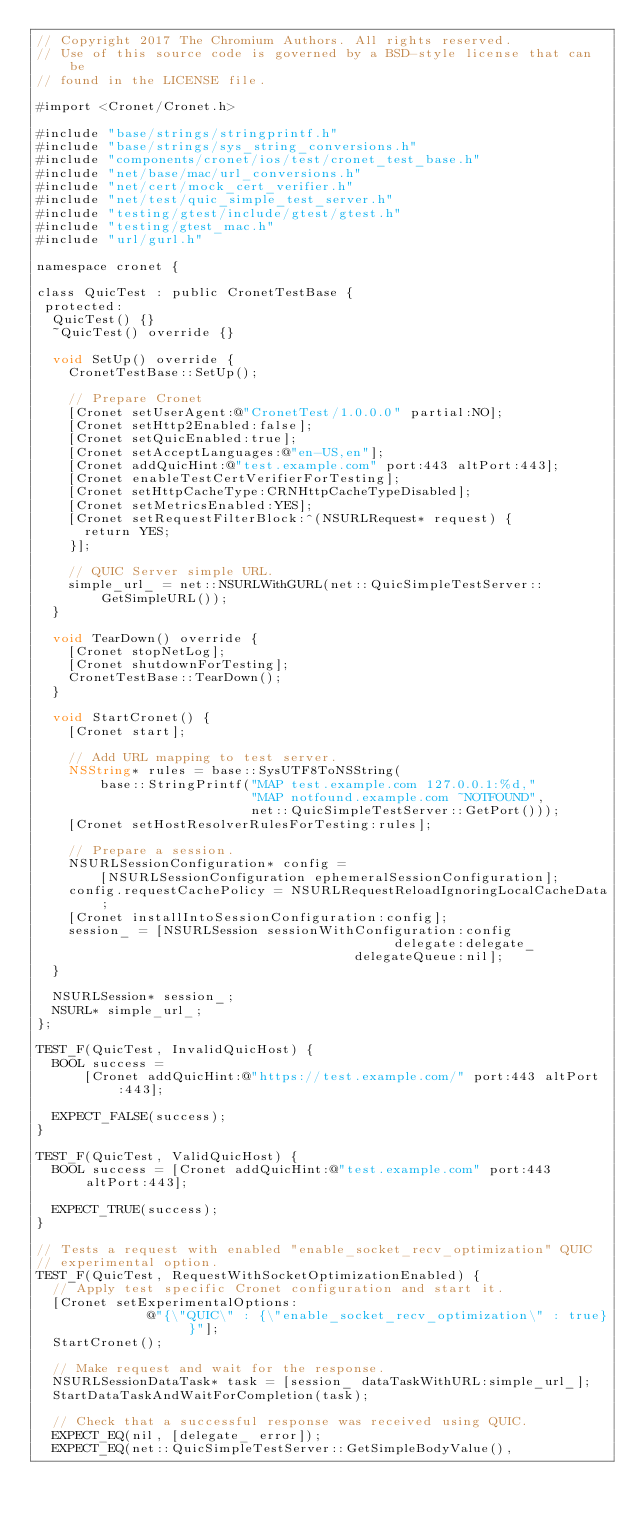<code> <loc_0><loc_0><loc_500><loc_500><_ObjectiveC_>// Copyright 2017 The Chromium Authors. All rights reserved.
// Use of this source code is governed by a BSD-style license that can be
// found in the LICENSE file.

#import <Cronet/Cronet.h>

#include "base/strings/stringprintf.h"
#include "base/strings/sys_string_conversions.h"
#include "components/cronet/ios/test/cronet_test_base.h"
#include "net/base/mac/url_conversions.h"
#include "net/cert/mock_cert_verifier.h"
#include "net/test/quic_simple_test_server.h"
#include "testing/gtest/include/gtest/gtest.h"
#include "testing/gtest_mac.h"
#include "url/gurl.h"

namespace cronet {

class QuicTest : public CronetTestBase {
 protected:
  QuicTest() {}
  ~QuicTest() override {}

  void SetUp() override {
    CronetTestBase::SetUp();

    // Prepare Cronet
    [Cronet setUserAgent:@"CronetTest/1.0.0.0" partial:NO];
    [Cronet setHttp2Enabled:false];
    [Cronet setQuicEnabled:true];
    [Cronet setAcceptLanguages:@"en-US,en"];
    [Cronet addQuicHint:@"test.example.com" port:443 altPort:443];
    [Cronet enableTestCertVerifierForTesting];
    [Cronet setHttpCacheType:CRNHttpCacheTypeDisabled];
    [Cronet setMetricsEnabled:YES];
    [Cronet setRequestFilterBlock:^(NSURLRequest* request) {
      return YES;
    }];

    // QUIC Server simple URL.
    simple_url_ = net::NSURLWithGURL(net::QuicSimpleTestServer::GetSimpleURL());
  }

  void TearDown() override {
    [Cronet stopNetLog];
    [Cronet shutdownForTesting];
    CronetTestBase::TearDown();
  }

  void StartCronet() {
    [Cronet start];

    // Add URL mapping to test server.
    NSString* rules = base::SysUTF8ToNSString(
        base::StringPrintf("MAP test.example.com 127.0.0.1:%d,"
                           "MAP notfound.example.com ~NOTFOUND",
                           net::QuicSimpleTestServer::GetPort()));
    [Cronet setHostResolverRulesForTesting:rules];

    // Prepare a session.
    NSURLSessionConfiguration* config =
        [NSURLSessionConfiguration ephemeralSessionConfiguration];
    config.requestCachePolicy = NSURLRequestReloadIgnoringLocalCacheData;
    [Cronet installIntoSessionConfiguration:config];
    session_ = [NSURLSession sessionWithConfiguration:config
                                             delegate:delegate_
                                        delegateQueue:nil];
  }

  NSURLSession* session_;
  NSURL* simple_url_;
};

TEST_F(QuicTest, InvalidQuicHost) {
  BOOL success =
      [Cronet addQuicHint:@"https://test.example.com/" port:443 altPort:443];

  EXPECT_FALSE(success);
}

TEST_F(QuicTest, ValidQuicHost) {
  BOOL success = [Cronet addQuicHint:@"test.example.com" port:443 altPort:443];

  EXPECT_TRUE(success);
}

// Tests a request with enabled "enable_socket_recv_optimization" QUIC
// experimental option.
TEST_F(QuicTest, RequestWithSocketOptimizationEnabled) {
  // Apply test specific Cronet configuration and start it.
  [Cronet setExperimentalOptions:
              @"{\"QUIC\" : {\"enable_socket_recv_optimization\" : true} }"];
  StartCronet();

  // Make request and wait for the response.
  NSURLSessionDataTask* task = [session_ dataTaskWithURL:simple_url_];
  StartDataTaskAndWaitForCompletion(task);

  // Check that a successful response was received using QUIC.
  EXPECT_EQ(nil, [delegate_ error]);
  EXPECT_EQ(net::QuicSimpleTestServer::GetSimpleBodyValue(),</code> 